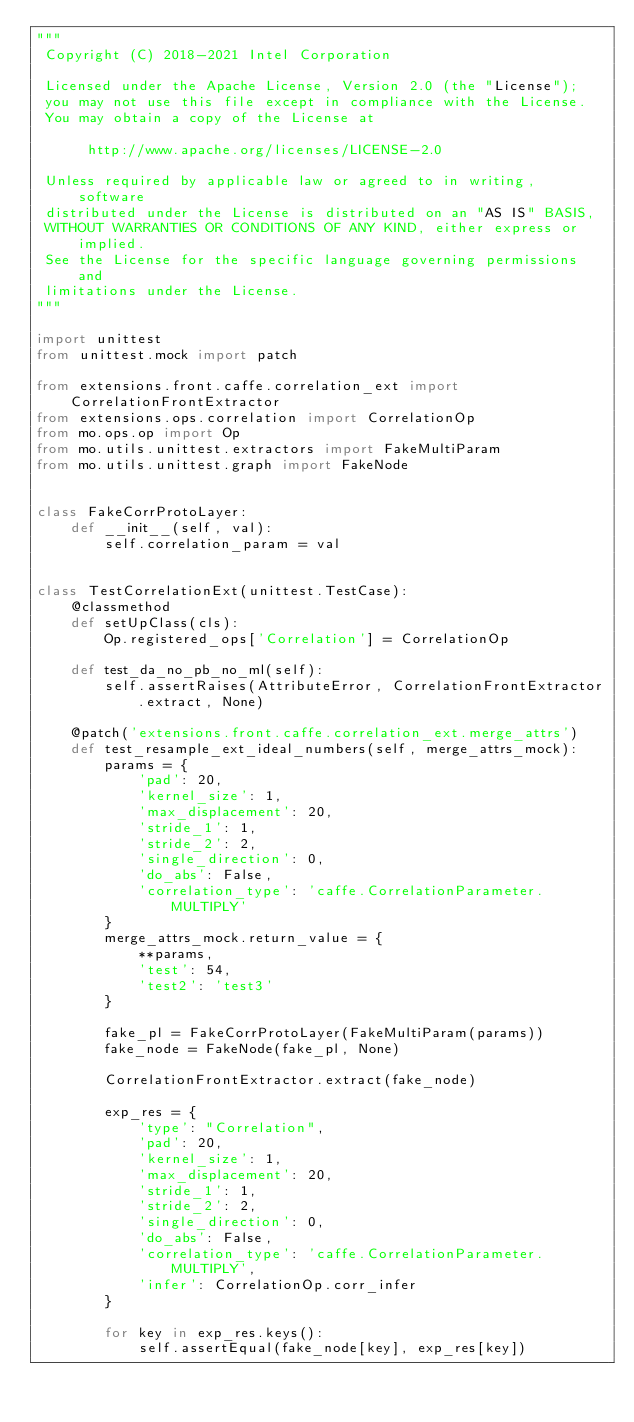<code> <loc_0><loc_0><loc_500><loc_500><_Python_>"""
 Copyright (C) 2018-2021 Intel Corporation

 Licensed under the Apache License, Version 2.0 (the "License");
 you may not use this file except in compliance with the License.
 You may obtain a copy of the License at

      http://www.apache.org/licenses/LICENSE-2.0

 Unless required by applicable law or agreed to in writing, software
 distributed under the License is distributed on an "AS IS" BASIS,
 WITHOUT WARRANTIES OR CONDITIONS OF ANY KIND, either express or implied.
 See the License for the specific language governing permissions and
 limitations under the License.
"""

import unittest
from unittest.mock import patch

from extensions.front.caffe.correlation_ext import CorrelationFrontExtractor
from extensions.ops.correlation import CorrelationOp
from mo.ops.op import Op
from mo.utils.unittest.extractors import FakeMultiParam
from mo.utils.unittest.graph import FakeNode


class FakeCorrProtoLayer:
    def __init__(self, val):
        self.correlation_param = val


class TestCorrelationExt(unittest.TestCase):
    @classmethod
    def setUpClass(cls):
        Op.registered_ops['Correlation'] = CorrelationOp

    def test_da_no_pb_no_ml(self):
        self.assertRaises(AttributeError, CorrelationFrontExtractor.extract, None)

    @patch('extensions.front.caffe.correlation_ext.merge_attrs')
    def test_resample_ext_ideal_numbers(self, merge_attrs_mock):
        params = {
            'pad': 20,
            'kernel_size': 1,
            'max_displacement': 20,
            'stride_1': 1,
            'stride_2': 2,
            'single_direction': 0,
            'do_abs': False,
            'correlation_type': 'caffe.CorrelationParameter.MULTIPLY'
        }
        merge_attrs_mock.return_value = {
            **params,
            'test': 54,
            'test2': 'test3'
        }

        fake_pl = FakeCorrProtoLayer(FakeMultiParam(params))
        fake_node = FakeNode(fake_pl, None)

        CorrelationFrontExtractor.extract(fake_node)

        exp_res = {
            'type': "Correlation",
            'pad': 20,
            'kernel_size': 1,
            'max_displacement': 20,
            'stride_1': 1,
            'stride_2': 2,
            'single_direction': 0,
            'do_abs': False,
            'correlation_type': 'caffe.CorrelationParameter.MULTIPLY',
            'infer': CorrelationOp.corr_infer
        }

        for key in exp_res.keys():
            self.assertEqual(fake_node[key], exp_res[key])
</code> 